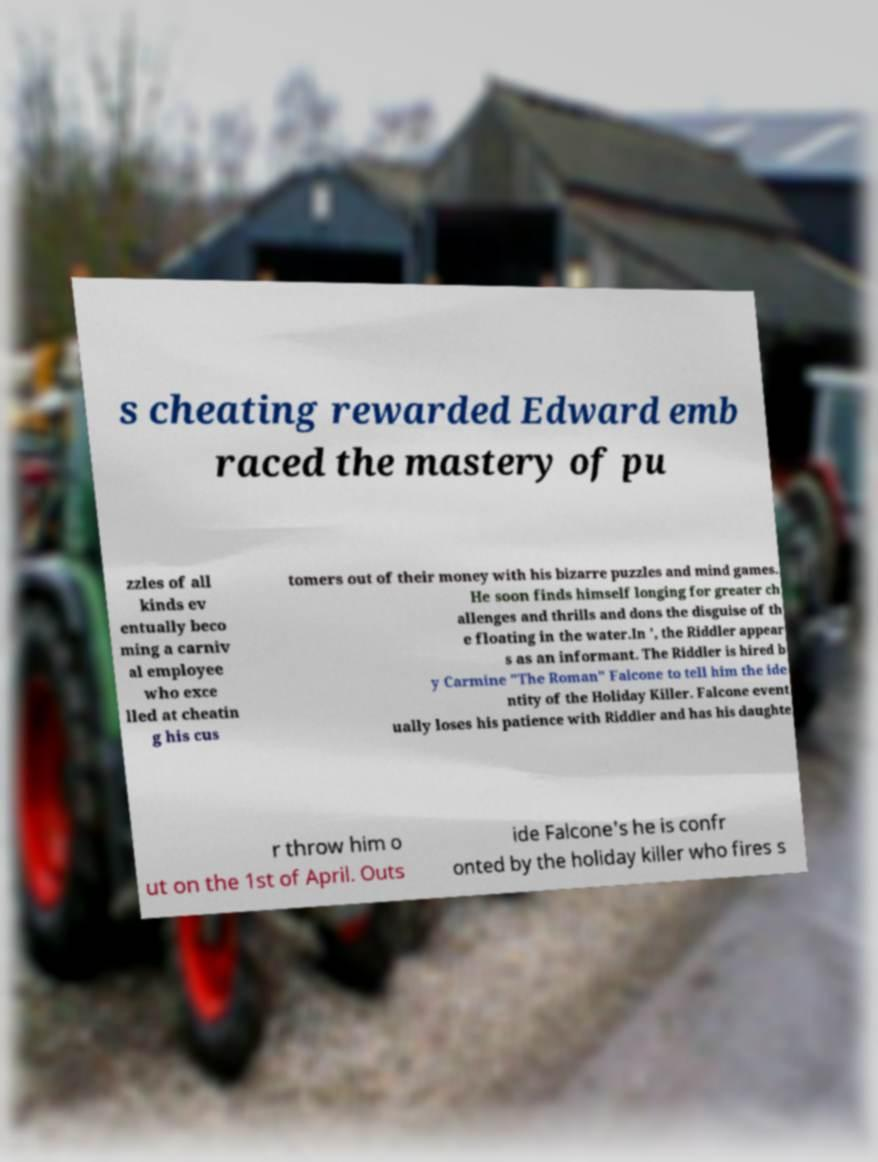There's text embedded in this image that I need extracted. Can you transcribe it verbatim? s cheating rewarded Edward emb raced the mastery of pu zzles of all kinds ev entually beco ming a carniv al employee who exce lled at cheatin g his cus tomers out of their money with his bizarre puzzles and mind games. He soon finds himself longing for greater ch allenges and thrills and dons the disguise of th e floating in the water.In ', the Riddler appear s as an informant. The Riddler is hired b y Carmine "The Roman" Falcone to tell him the ide ntity of the Holiday Killer. Falcone event ually loses his patience with Riddler and has his daughte r throw him o ut on the 1st of April. Outs ide Falcone's he is confr onted by the holiday killer who fires s 